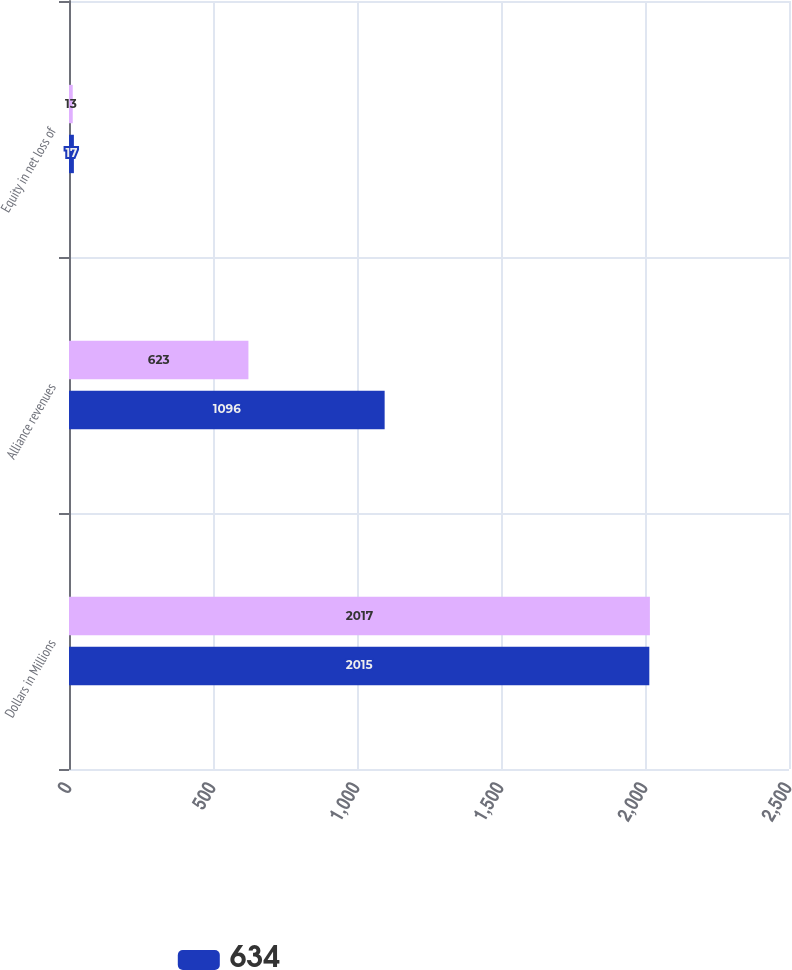Convert chart to OTSL. <chart><loc_0><loc_0><loc_500><loc_500><stacked_bar_chart><ecel><fcel>Dollars in Millions<fcel>Alliance revenues<fcel>Equity in net loss of<nl><fcel>nan<fcel>2017<fcel>623<fcel>13<nl><fcel>634<fcel>2015<fcel>1096<fcel>17<nl></chart> 